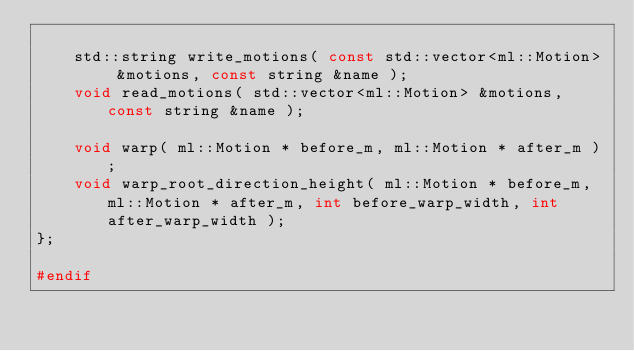<code> <loc_0><loc_0><loc_500><loc_500><_C_>
	std::string write_motions( const std::vector<ml::Motion> &motions, const string &name );
	void read_motions( std::vector<ml::Motion> &motions, const string &name );

	void warp( ml::Motion * before_m, ml::Motion * after_m );
	void warp_root_direction_height( ml::Motion * before_m, ml::Motion * after_m, int before_warp_width, int after_warp_width );
};

#endif</code> 